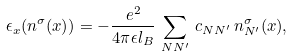<formula> <loc_0><loc_0><loc_500><loc_500>\epsilon _ { x } ( n ^ { \sigma } ( x ) ) = - \frac { e ^ { 2 } } { 4 \pi \epsilon l _ { B } } \, \sum _ { N N ^ { \prime } } \, c _ { N N ^ { \prime } } \, n ^ { \sigma } _ { N ^ { \prime } } ( x ) ,</formula> 